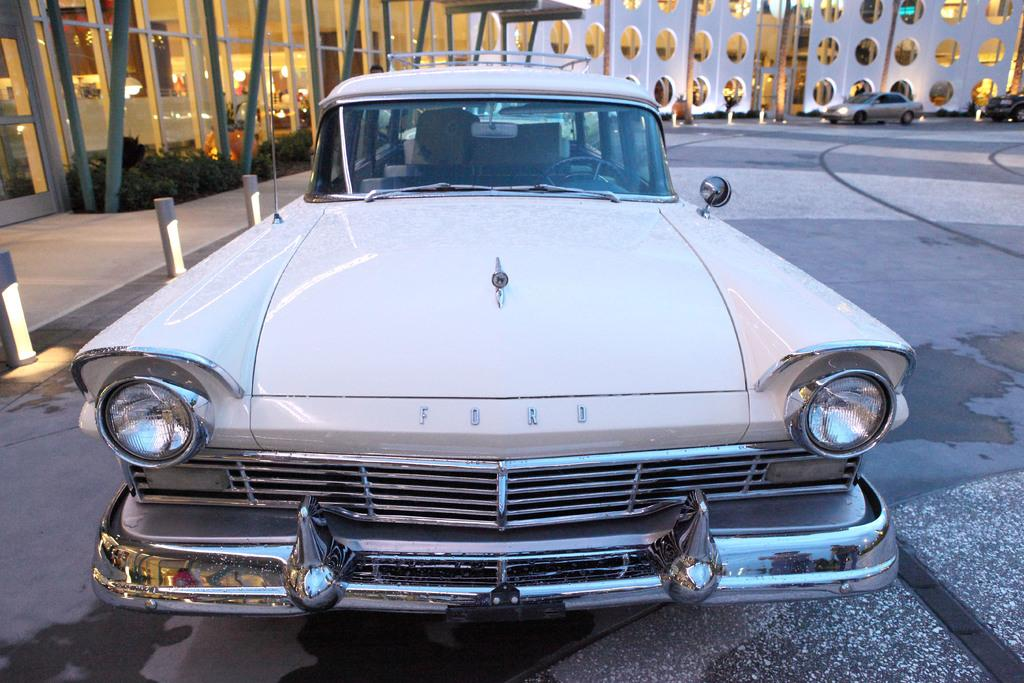What is the main subject of the image? The main subject of the image is a car on the road. Can you describe any other structures or objects in the image? Yes, there is a building with plants in the image. Are there any other vehicles visible in the image? Yes, there are two cars in front of the building. What type of grape is being cut with scissors in the image? There is no grape or scissors present in the image. Can you hear any thunder in the image? There is no sound in the image, so it is impossible to determine if there is thunder. 